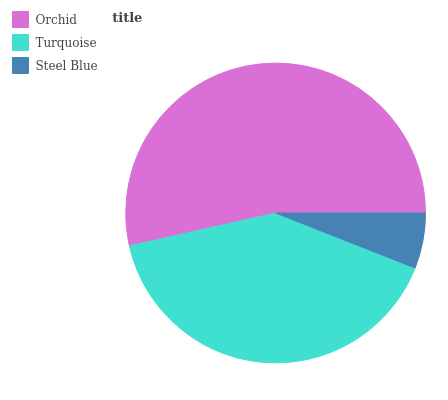Is Steel Blue the minimum?
Answer yes or no. Yes. Is Orchid the maximum?
Answer yes or no. Yes. Is Turquoise the minimum?
Answer yes or no. No. Is Turquoise the maximum?
Answer yes or no. No. Is Orchid greater than Turquoise?
Answer yes or no. Yes. Is Turquoise less than Orchid?
Answer yes or no. Yes. Is Turquoise greater than Orchid?
Answer yes or no. No. Is Orchid less than Turquoise?
Answer yes or no. No. Is Turquoise the high median?
Answer yes or no. Yes. Is Turquoise the low median?
Answer yes or no. Yes. Is Steel Blue the high median?
Answer yes or no. No. Is Steel Blue the low median?
Answer yes or no. No. 